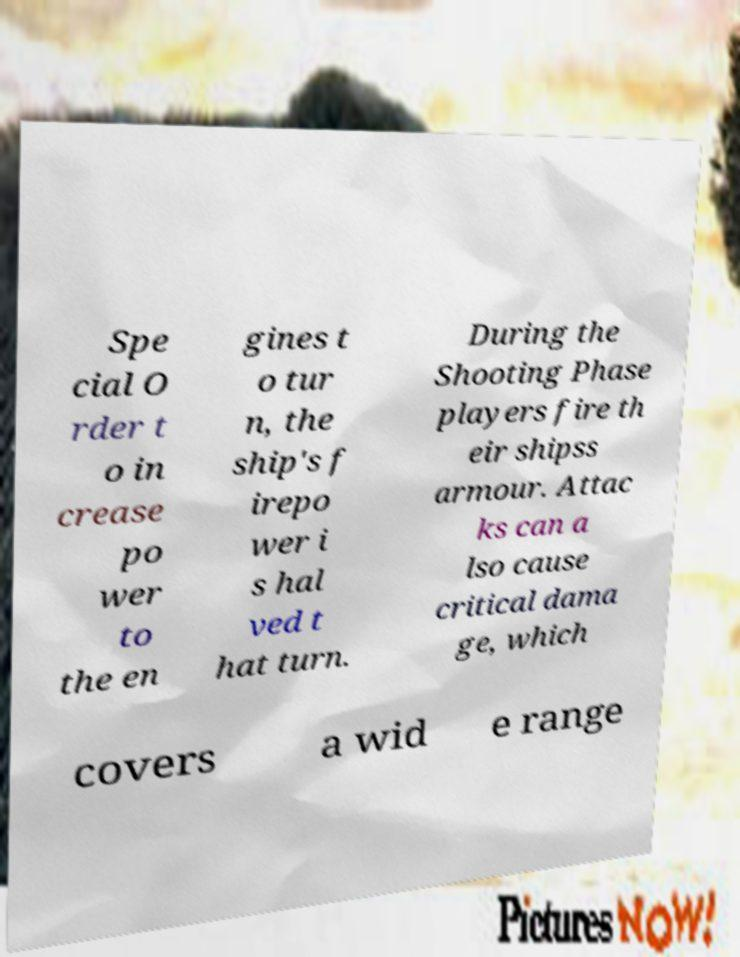For documentation purposes, I need the text within this image transcribed. Could you provide that? Spe cial O rder t o in crease po wer to the en gines t o tur n, the ship's f irepo wer i s hal ved t hat turn. During the Shooting Phase players fire th eir shipss armour. Attac ks can a lso cause critical dama ge, which covers a wid e range 